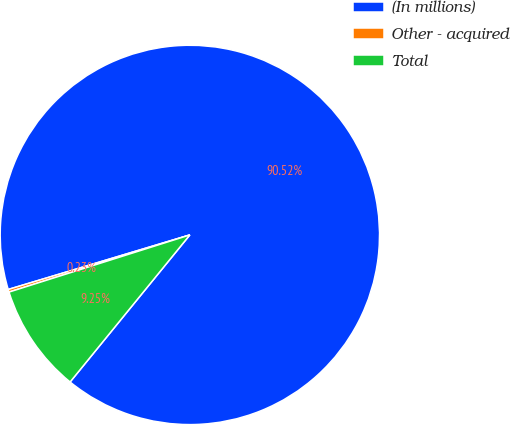Convert chart. <chart><loc_0><loc_0><loc_500><loc_500><pie_chart><fcel>(In millions)<fcel>Other - acquired<fcel>Total<nl><fcel>90.52%<fcel>0.23%<fcel>9.25%<nl></chart> 